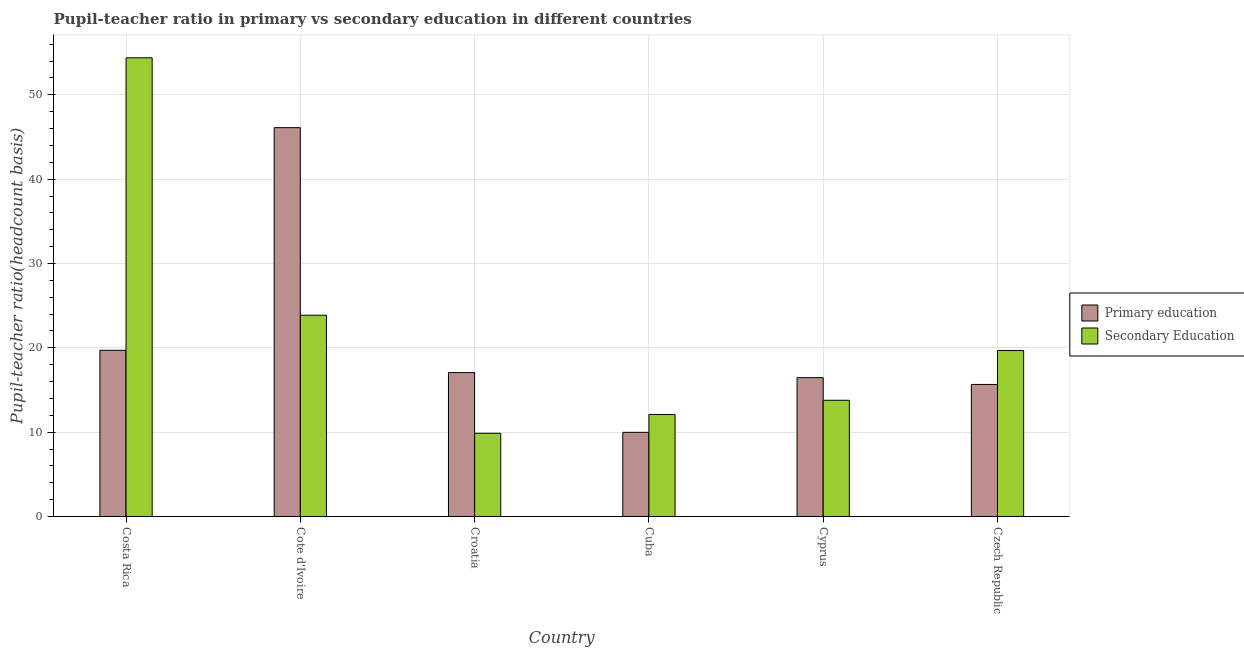How many different coloured bars are there?
Your answer should be compact. 2. How many groups of bars are there?
Offer a terse response. 6. Are the number of bars per tick equal to the number of legend labels?
Your answer should be compact. Yes. What is the label of the 6th group of bars from the left?
Your answer should be compact. Czech Republic. What is the pupil-teacher ratio in primary education in Costa Rica?
Your answer should be very brief. 19.71. Across all countries, what is the maximum pupil teacher ratio on secondary education?
Give a very brief answer. 54.39. Across all countries, what is the minimum pupil-teacher ratio in primary education?
Offer a terse response. 9.98. In which country was the pupil-teacher ratio in primary education minimum?
Make the answer very short. Cuba. What is the total pupil-teacher ratio in primary education in the graph?
Provide a succinct answer. 124.98. What is the difference between the pupil teacher ratio on secondary education in Cote d'Ivoire and that in Cuba?
Your answer should be compact. 11.77. What is the difference between the pupil-teacher ratio in primary education in Cuba and the pupil teacher ratio on secondary education in Czech Republic?
Keep it short and to the point. -9.71. What is the average pupil teacher ratio on secondary education per country?
Your answer should be compact. 22.28. What is the difference between the pupil-teacher ratio in primary education and pupil teacher ratio on secondary education in Cyprus?
Ensure brevity in your answer.  2.68. In how many countries, is the pupil teacher ratio on secondary education greater than 52 ?
Provide a short and direct response. 1. What is the ratio of the pupil teacher ratio on secondary education in Cote d'Ivoire to that in Czech Republic?
Your answer should be very brief. 1.21. What is the difference between the highest and the second highest pupil teacher ratio on secondary education?
Your response must be concise. 30.52. What is the difference between the highest and the lowest pupil-teacher ratio in primary education?
Make the answer very short. 36.13. In how many countries, is the pupil teacher ratio on secondary education greater than the average pupil teacher ratio on secondary education taken over all countries?
Your answer should be very brief. 2. Is the sum of the pupil teacher ratio on secondary education in Cyprus and Czech Republic greater than the maximum pupil-teacher ratio in primary education across all countries?
Give a very brief answer. No. What does the 2nd bar from the right in Cuba represents?
Give a very brief answer. Primary education. How many bars are there?
Give a very brief answer. 12. Are all the bars in the graph horizontal?
Give a very brief answer. No. How many countries are there in the graph?
Make the answer very short. 6. What is the difference between two consecutive major ticks on the Y-axis?
Provide a succinct answer. 10. Does the graph contain any zero values?
Your answer should be compact. No. Does the graph contain grids?
Keep it short and to the point. Yes. Where does the legend appear in the graph?
Your answer should be very brief. Center right. How many legend labels are there?
Your response must be concise. 2. How are the legend labels stacked?
Ensure brevity in your answer.  Vertical. What is the title of the graph?
Make the answer very short. Pupil-teacher ratio in primary vs secondary education in different countries. Does "Short-term debt" appear as one of the legend labels in the graph?
Keep it short and to the point. No. What is the label or title of the X-axis?
Provide a short and direct response. Country. What is the label or title of the Y-axis?
Give a very brief answer. Pupil-teacher ratio(headcount basis). What is the Pupil-teacher ratio(headcount basis) in Primary education in Costa Rica?
Keep it short and to the point. 19.71. What is the Pupil-teacher ratio(headcount basis) of Secondary Education in Costa Rica?
Your answer should be very brief. 54.39. What is the Pupil-teacher ratio(headcount basis) of Primary education in Cote d'Ivoire?
Ensure brevity in your answer.  46.11. What is the Pupil-teacher ratio(headcount basis) in Secondary Education in Cote d'Ivoire?
Offer a very short reply. 23.87. What is the Pupil-teacher ratio(headcount basis) in Primary education in Croatia?
Your answer should be very brief. 17.06. What is the Pupil-teacher ratio(headcount basis) of Secondary Education in Croatia?
Offer a terse response. 9.87. What is the Pupil-teacher ratio(headcount basis) of Primary education in Cuba?
Provide a short and direct response. 9.98. What is the Pupil-teacher ratio(headcount basis) of Secondary Education in Cuba?
Provide a short and direct response. 12.1. What is the Pupil-teacher ratio(headcount basis) of Primary education in Cyprus?
Offer a very short reply. 16.46. What is the Pupil-teacher ratio(headcount basis) of Secondary Education in Cyprus?
Offer a very short reply. 13.78. What is the Pupil-teacher ratio(headcount basis) of Primary education in Czech Republic?
Offer a very short reply. 15.66. What is the Pupil-teacher ratio(headcount basis) of Secondary Education in Czech Republic?
Offer a terse response. 19.69. Across all countries, what is the maximum Pupil-teacher ratio(headcount basis) of Primary education?
Your answer should be compact. 46.11. Across all countries, what is the maximum Pupil-teacher ratio(headcount basis) of Secondary Education?
Give a very brief answer. 54.39. Across all countries, what is the minimum Pupil-teacher ratio(headcount basis) of Primary education?
Ensure brevity in your answer.  9.98. Across all countries, what is the minimum Pupil-teacher ratio(headcount basis) of Secondary Education?
Your answer should be very brief. 9.87. What is the total Pupil-teacher ratio(headcount basis) in Primary education in the graph?
Keep it short and to the point. 124.98. What is the total Pupil-teacher ratio(headcount basis) of Secondary Education in the graph?
Your response must be concise. 133.69. What is the difference between the Pupil-teacher ratio(headcount basis) in Primary education in Costa Rica and that in Cote d'Ivoire?
Keep it short and to the point. -26.4. What is the difference between the Pupil-teacher ratio(headcount basis) in Secondary Education in Costa Rica and that in Cote d'Ivoire?
Provide a short and direct response. 30.52. What is the difference between the Pupil-teacher ratio(headcount basis) in Primary education in Costa Rica and that in Croatia?
Your response must be concise. 2.65. What is the difference between the Pupil-teacher ratio(headcount basis) of Secondary Education in Costa Rica and that in Croatia?
Offer a very short reply. 44.52. What is the difference between the Pupil-teacher ratio(headcount basis) of Primary education in Costa Rica and that in Cuba?
Offer a very short reply. 9.73. What is the difference between the Pupil-teacher ratio(headcount basis) of Secondary Education in Costa Rica and that in Cuba?
Keep it short and to the point. 42.29. What is the difference between the Pupil-teacher ratio(headcount basis) in Primary education in Costa Rica and that in Cyprus?
Keep it short and to the point. 3.24. What is the difference between the Pupil-teacher ratio(headcount basis) of Secondary Education in Costa Rica and that in Cyprus?
Your response must be concise. 40.61. What is the difference between the Pupil-teacher ratio(headcount basis) of Primary education in Costa Rica and that in Czech Republic?
Ensure brevity in your answer.  4.05. What is the difference between the Pupil-teacher ratio(headcount basis) of Secondary Education in Costa Rica and that in Czech Republic?
Your answer should be very brief. 34.7. What is the difference between the Pupil-teacher ratio(headcount basis) in Primary education in Cote d'Ivoire and that in Croatia?
Your answer should be compact. 29.05. What is the difference between the Pupil-teacher ratio(headcount basis) in Secondary Education in Cote d'Ivoire and that in Croatia?
Provide a succinct answer. 14. What is the difference between the Pupil-teacher ratio(headcount basis) in Primary education in Cote d'Ivoire and that in Cuba?
Offer a very short reply. 36.13. What is the difference between the Pupil-teacher ratio(headcount basis) in Secondary Education in Cote d'Ivoire and that in Cuba?
Ensure brevity in your answer.  11.77. What is the difference between the Pupil-teacher ratio(headcount basis) of Primary education in Cote d'Ivoire and that in Cyprus?
Offer a terse response. 29.65. What is the difference between the Pupil-teacher ratio(headcount basis) of Secondary Education in Cote d'Ivoire and that in Cyprus?
Make the answer very short. 10.09. What is the difference between the Pupil-teacher ratio(headcount basis) of Primary education in Cote d'Ivoire and that in Czech Republic?
Make the answer very short. 30.45. What is the difference between the Pupil-teacher ratio(headcount basis) of Secondary Education in Cote d'Ivoire and that in Czech Republic?
Your answer should be very brief. 4.18. What is the difference between the Pupil-teacher ratio(headcount basis) of Primary education in Croatia and that in Cuba?
Offer a very short reply. 7.08. What is the difference between the Pupil-teacher ratio(headcount basis) of Secondary Education in Croatia and that in Cuba?
Ensure brevity in your answer.  -2.23. What is the difference between the Pupil-teacher ratio(headcount basis) of Primary education in Croatia and that in Cyprus?
Your response must be concise. 0.6. What is the difference between the Pupil-teacher ratio(headcount basis) in Secondary Education in Croatia and that in Cyprus?
Offer a very short reply. -3.91. What is the difference between the Pupil-teacher ratio(headcount basis) in Primary education in Croatia and that in Czech Republic?
Ensure brevity in your answer.  1.4. What is the difference between the Pupil-teacher ratio(headcount basis) of Secondary Education in Croatia and that in Czech Republic?
Offer a very short reply. -9.82. What is the difference between the Pupil-teacher ratio(headcount basis) of Primary education in Cuba and that in Cyprus?
Offer a terse response. -6.48. What is the difference between the Pupil-teacher ratio(headcount basis) in Secondary Education in Cuba and that in Cyprus?
Keep it short and to the point. -1.68. What is the difference between the Pupil-teacher ratio(headcount basis) in Primary education in Cuba and that in Czech Republic?
Keep it short and to the point. -5.68. What is the difference between the Pupil-teacher ratio(headcount basis) in Secondary Education in Cuba and that in Czech Republic?
Give a very brief answer. -7.59. What is the difference between the Pupil-teacher ratio(headcount basis) in Primary education in Cyprus and that in Czech Republic?
Offer a terse response. 0.81. What is the difference between the Pupil-teacher ratio(headcount basis) of Secondary Education in Cyprus and that in Czech Republic?
Ensure brevity in your answer.  -5.9. What is the difference between the Pupil-teacher ratio(headcount basis) of Primary education in Costa Rica and the Pupil-teacher ratio(headcount basis) of Secondary Education in Cote d'Ivoire?
Your answer should be compact. -4.16. What is the difference between the Pupil-teacher ratio(headcount basis) in Primary education in Costa Rica and the Pupil-teacher ratio(headcount basis) in Secondary Education in Croatia?
Ensure brevity in your answer.  9.84. What is the difference between the Pupil-teacher ratio(headcount basis) in Primary education in Costa Rica and the Pupil-teacher ratio(headcount basis) in Secondary Education in Cuba?
Offer a terse response. 7.61. What is the difference between the Pupil-teacher ratio(headcount basis) in Primary education in Costa Rica and the Pupil-teacher ratio(headcount basis) in Secondary Education in Cyprus?
Ensure brevity in your answer.  5.93. What is the difference between the Pupil-teacher ratio(headcount basis) of Primary education in Costa Rica and the Pupil-teacher ratio(headcount basis) of Secondary Education in Czech Republic?
Your answer should be very brief. 0.02. What is the difference between the Pupil-teacher ratio(headcount basis) in Primary education in Cote d'Ivoire and the Pupil-teacher ratio(headcount basis) in Secondary Education in Croatia?
Provide a succinct answer. 36.24. What is the difference between the Pupil-teacher ratio(headcount basis) of Primary education in Cote d'Ivoire and the Pupil-teacher ratio(headcount basis) of Secondary Education in Cuba?
Ensure brevity in your answer.  34.01. What is the difference between the Pupil-teacher ratio(headcount basis) in Primary education in Cote d'Ivoire and the Pupil-teacher ratio(headcount basis) in Secondary Education in Cyprus?
Ensure brevity in your answer.  32.33. What is the difference between the Pupil-teacher ratio(headcount basis) in Primary education in Cote d'Ivoire and the Pupil-teacher ratio(headcount basis) in Secondary Education in Czech Republic?
Your answer should be very brief. 26.42. What is the difference between the Pupil-teacher ratio(headcount basis) of Primary education in Croatia and the Pupil-teacher ratio(headcount basis) of Secondary Education in Cuba?
Keep it short and to the point. 4.96. What is the difference between the Pupil-teacher ratio(headcount basis) in Primary education in Croatia and the Pupil-teacher ratio(headcount basis) in Secondary Education in Cyprus?
Make the answer very short. 3.28. What is the difference between the Pupil-teacher ratio(headcount basis) of Primary education in Croatia and the Pupil-teacher ratio(headcount basis) of Secondary Education in Czech Republic?
Give a very brief answer. -2.62. What is the difference between the Pupil-teacher ratio(headcount basis) in Primary education in Cuba and the Pupil-teacher ratio(headcount basis) in Secondary Education in Cyprus?
Offer a terse response. -3.8. What is the difference between the Pupil-teacher ratio(headcount basis) in Primary education in Cuba and the Pupil-teacher ratio(headcount basis) in Secondary Education in Czech Republic?
Keep it short and to the point. -9.71. What is the difference between the Pupil-teacher ratio(headcount basis) of Primary education in Cyprus and the Pupil-teacher ratio(headcount basis) of Secondary Education in Czech Republic?
Provide a short and direct response. -3.22. What is the average Pupil-teacher ratio(headcount basis) in Primary education per country?
Provide a short and direct response. 20.83. What is the average Pupil-teacher ratio(headcount basis) in Secondary Education per country?
Your answer should be compact. 22.28. What is the difference between the Pupil-teacher ratio(headcount basis) of Primary education and Pupil-teacher ratio(headcount basis) of Secondary Education in Costa Rica?
Offer a terse response. -34.68. What is the difference between the Pupil-teacher ratio(headcount basis) of Primary education and Pupil-teacher ratio(headcount basis) of Secondary Education in Cote d'Ivoire?
Provide a short and direct response. 22.24. What is the difference between the Pupil-teacher ratio(headcount basis) of Primary education and Pupil-teacher ratio(headcount basis) of Secondary Education in Croatia?
Give a very brief answer. 7.19. What is the difference between the Pupil-teacher ratio(headcount basis) of Primary education and Pupil-teacher ratio(headcount basis) of Secondary Education in Cuba?
Offer a terse response. -2.12. What is the difference between the Pupil-teacher ratio(headcount basis) in Primary education and Pupil-teacher ratio(headcount basis) in Secondary Education in Cyprus?
Offer a terse response. 2.68. What is the difference between the Pupil-teacher ratio(headcount basis) of Primary education and Pupil-teacher ratio(headcount basis) of Secondary Education in Czech Republic?
Make the answer very short. -4.03. What is the ratio of the Pupil-teacher ratio(headcount basis) in Primary education in Costa Rica to that in Cote d'Ivoire?
Keep it short and to the point. 0.43. What is the ratio of the Pupil-teacher ratio(headcount basis) of Secondary Education in Costa Rica to that in Cote d'Ivoire?
Your answer should be compact. 2.28. What is the ratio of the Pupil-teacher ratio(headcount basis) of Primary education in Costa Rica to that in Croatia?
Offer a terse response. 1.16. What is the ratio of the Pupil-teacher ratio(headcount basis) of Secondary Education in Costa Rica to that in Croatia?
Your answer should be compact. 5.51. What is the ratio of the Pupil-teacher ratio(headcount basis) of Primary education in Costa Rica to that in Cuba?
Provide a short and direct response. 1.98. What is the ratio of the Pupil-teacher ratio(headcount basis) of Secondary Education in Costa Rica to that in Cuba?
Offer a terse response. 4.5. What is the ratio of the Pupil-teacher ratio(headcount basis) in Primary education in Costa Rica to that in Cyprus?
Your answer should be compact. 1.2. What is the ratio of the Pupil-teacher ratio(headcount basis) in Secondary Education in Costa Rica to that in Cyprus?
Offer a very short reply. 3.95. What is the ratio of the Pupil-teacher ratio(headcount basis) in Primary education in Costa Rica to that in Czech Republic?
Keep it short and to the point. 1.26. What is the ratio of the Pupil-teacher ratio(headcount basis) in Secondary Education in Costa Rica to that in Czech Republic?
Keep it short and to the point. 2.76. What is the ratio of the Pupil-teacher ratio(headcount basis) in Primary education in Cote d'Ivoire to that in Croatia?
Your answer should be compact. 2.7. What is the ratio of the Pupil-teacher ratio(headcount basis) in Secondary Education in Cote d'Ivoire to that in Croatia?
Give a very brief answer. 2.42. What is the ratio of the Pupil-teacher ratio(headcount basis) of Primary education in Cote d'Ivoire to that in Cuba?
Your answer should be very brief. 4.62. What is the ratio of the Pupil-teacher ratio(headcount basis) of Secondary Education in Cote d'Ivoire to that in Cuba?
Give a very brief answer. 1.97. What is the ratio of the Pupil-teacher ratio(headcount basis) in Primary education in Cote d'Ivoire to that in Cyprus?
Your response must be concise. 2.8. What is the ratio of the Pupil-teacher ratio(headcount basis) of Secondary Education in Cote d'Ivoire to that in Cyprus?
Keep it short and to the point. 1.73. What is the ratio of the Pupil-teacher ratio(headcount basis) of Primary education in Cote d'Ivoire to that in Czech Republic?
Make the answer very short. 2.94. What is the ratio of the Pupil-teacher ratio(headcount basis) in Secondary Education in Cote d'Ivoire to that in Czech Republic?
Your response must be concise. 1.21. What is the ratio of the Pupil-teacher ratio(headcount basis) in Primary education in Croatia to that in Cuba?
Make the answer very short. 1.71. What is the ratio of the Pupil-teacher ratio(headcount basis) in Secondary Education in Croatia to that in Cuba?
Your response must be concise. 0.82. What is the ratio of the Pupil-teacher ratio(headcount basis) of Primary education in Croatia to that in Cyprus?
Your answer should be compact. 1.04. What is the ratio of the Pupil-teacher ratio(headcount basis) of Secondary Education in Croatia to that in Cyprus?
Keep it short and to the point. 0.72. What is the ratio of the Pupil-teacher ratio(headcount basis) in Primary education in Croatia to that in Czech Republic?
Your response must be concise. 1.09. What is the ratio of the Pupil-teacher ratio(headcount basis) in Secondary Education in Croatia to that in Czech Republic?
Give a very brief answer. 0.5. What is the ratio of the Pupil-teacher ratio(headcount basis) in Primary education in Cuba to that in Cyprus?
Provide a succinct answer. 0.61. What is the ratio of the Pupil-teacher ratio(headcount basis) in Secondary Education in Cuba to that in Cyprus?
Offer a very short reply. 0.88. What is the ratio of the Pupil-teacher ratio(headcount basis) of Primary education in Cuba to that in Czech Republic?
Give a very brief answer. 0.64. What is the ratio of the Pupil-teacher ratio(headcount basis) in Secondary Education in Cuba to that in Czech Republic?
Provide a succinct answer. 0.61. What is the ratio of the Pupil-teacher ratio(headcount basis) of Primary education in Cyprus to that in Czech Republic?
Provide a succinct answer. 1.05. What is the ratio of the Pupil-teacher ratio(headcount basis) in Secondary Education in Cyprus to that in Czech Republic?
Make the answer very short. 0.7. What is the difference between the highest and the second highest Pupil-teacher ratio(headcount basis) in Primary education?
Ensure brevity in your answer.  26.4. What is the difference between the highest and the second highest Pupil-teacher ratio(headcount basis) of Secondary Education?
Give a very brief answer. 30.52. What is the difference between the highest and the lowest Pupil-teacher ratio(headcount basis) in Primary education?
Provide a succinct answer. 36.13. What is the difference between the highest and the lowest Pupil-teacher ratio(headcount basis) of Secondary Education?
Your response must be concise. 44.52. 